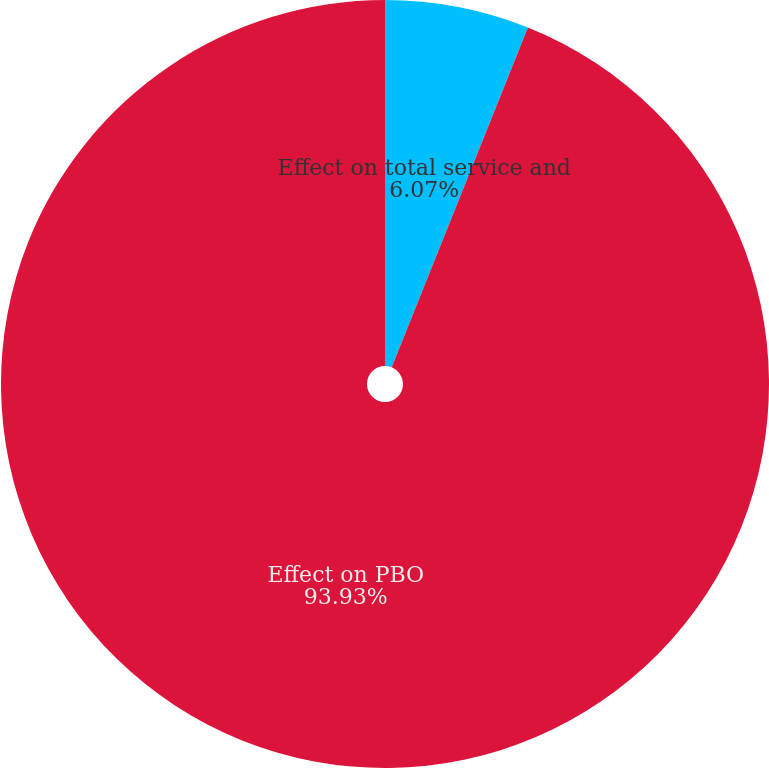Convert chart to OTSL. <chart><loc_0><loc_0><loc_500><loc_500><pie_chart><fcel>Effect on total service and<fcel>Effect on PBO<nl><fcel>6.07%<fcel>93.93%<nl></chart> 